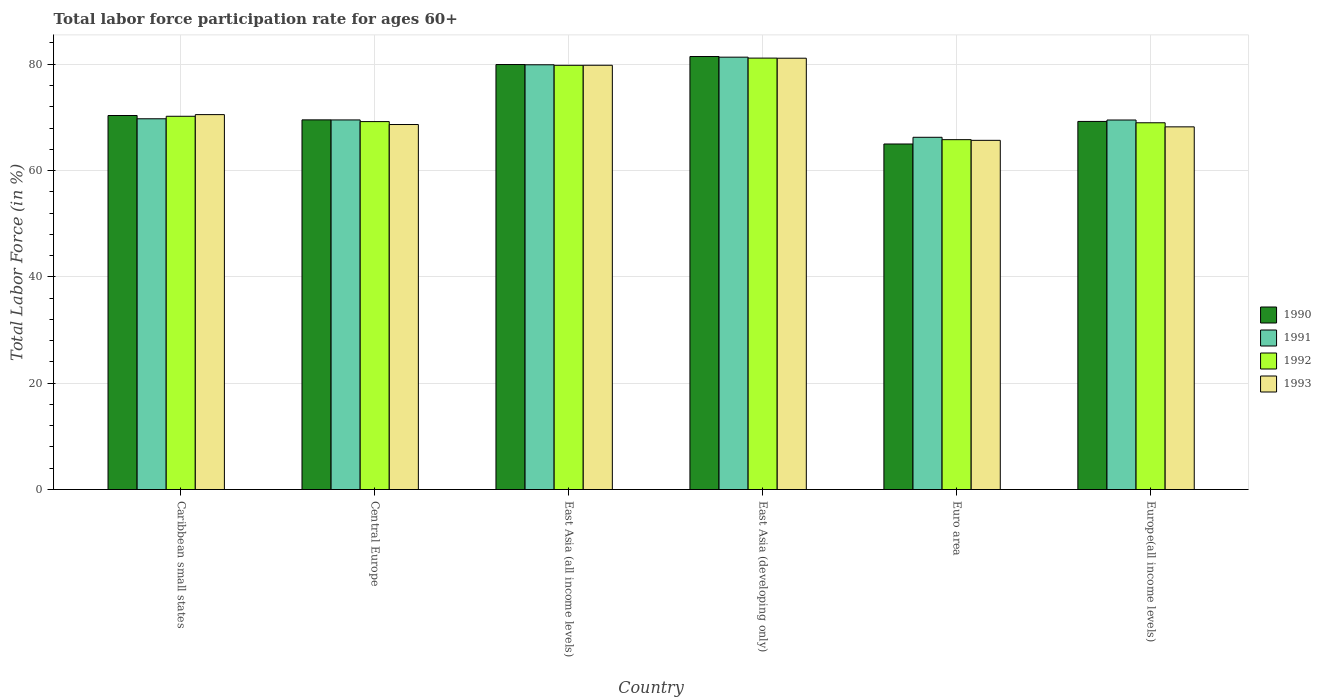How many different coloured bars are there?
Provide a succinct answer. 4. How many groups of bars are there?
Keep it short and to the point. 6. Are the number of bars on each tick of the X-axis equal?
Ensure brevity in your answer.  Yes. How many bars are there on the 1st tick from the left?
Give a very brief answer. 4. What is the label of the 4th group of bars from the left?
Provide a short and direct response. East Asia (developing only). In how many cases, is the number of bars for a given country not equal to the number of legend labels?
Make the answer very short. 0. What is the labor force participation rate in 1993 in East Asia (developing only)?
Your answer should be very brief. 81.14. Across all countries, what is the maximum labor force participation rate in 1993?
Give a very brief answer. 81.14. Across all countries, what is the minimum labor force participation rate in 1992?
Your answer should be very brief. 65.81. In which country was the labor force participation rate in 1992 maximum?
Provide a succinct answer. East Asia (developing only). In which country was the labor force participation rate in 1990 minimum?
Offer a very short reply. Euro area. What is the total labor force participation rate in 1992 in the graph?
Offer a terse response. 435.19. What is the difference between the labor force participation rate in 1990 in Central Europe and that in Europe(all income levels)?
Offer a very short reply. 0.29. What is the difference between the labor force participation rate in 1990 in Caribbean small states and the labor force participation rate in 1991 in East Asia (all income levels)?
Provide a short and direct response. -9.54. What is the average labor force participation rate in 1992 per country?
Give a very brief answer. 72.53. What is the difference between the labor force participation rate of/in 1990 and labor force participation rate of/in 1993 in Caribbean small states?
Make the answer very short. -0.17. What is the ratio of the labor force participation rate in 1991 in Central Europe to that in East Asia (all income levels)?
Keep it short and to the point. 0.87. What is the difference between the highest and the second highest labor force participation rate in 1992?
Provide a succinct answer. 10.94. What is the difference between the highest and the lowest labor force participation rate in 1993?
Ensure brevity in your answer.  15.45. In how many countries, is the labor force participation rate in 1993 greater than the average labor force participation rate in 1993 taken over all countries?
Offer a terse response. 2. Is the sum of the labor force participation rate in 1990 in Caribbean small states and East Asia (developing only) greater than the maximum labor force participation rate in 1991 across all countries?
Your answer should be compact. Yes. What does the 3rd bar from the left in East Asia (all income levels) represents?
Ensure brevity in your answer.  1992. What does the 3rd bar from the right in East Asia (all income levels) represents?
Keep it short and to the point. 1991. Is it the case that in every country, the sum of the labor force participation rate in 1993 and labor force participation rate in 1992 is greater than the labor force participation rate in 1990?
Your answer should be compact. Yes. How many bars are there?
Keep it short and to the point. 24. What is the difference between two consecutive major ticks on the Y-axis?
Give a very brief answer. 20. Where does the legend appear in the graph?
Your answer should be compact. Center right. What is the title of the graph?
Provide a short and direct response. Total labor force participation rate for ages 60+. What is the label or title of the X-axis?
Your response must be concise. Country. What is the Total Labor Force (in %) in 1990 in Caribbean small states?
Provide a short and direct response. 70.36. What is the Total Labor Force (in %) in 1991 in Caribbean small states?
Offer a very short reply. 69.74. What is the Total Labor Force (in %) of 1992 in Caribbean small states?
Ensure brevity in your answer.  70.21. What is the Total Labor Force (in %) in 1993 in Caribbean small states?
Offer a very short reply. 70.53. What is the Total Labor Force (in %) in 1990 in Central Europe?
Give a very brief answer. 69.54. What is the Total Labor Force (in %) of 1991 in Central Europe?
Offer a very short reply. 69.52. What is the Total Labor Force (in %) of 1992 in Central Europe?
Make the answer very short. 69.21. What is the Total Labor Force (in %) of 1993 in Central Europe?
Give a very brief answer. 68.66. What is the Total Labor Force (in %) of 1990 in East Asia (all income levels)?
Offer a very short reply. 79.95. What is the Total Labor Force (in %) of 1991 in East Asia (all income levels)?
Make the answer very short. 79.9. What is the Total Labor Force (in %) of 1992 in East Asia (all income levels)?
Your response must be concise. 79.8. What is the Total Labor Force (in %) of 1993 in East Asia (all income levels)?
Your response must be concise. 79.81. What is the Total Labor Force (in %) of 1990 in East Asia (developing only)?
Your response must be concise. 81.45. What is the Total Labor Force (in %) of 1991 in East Asia (developing only)?
Your answer should be very brief. 81.33. What is the Total Labor Force (in %) of 1992 in East Asia (developing only)?
Offer a very short reply. 81.16. What is the Total Labor Force (in %) of 1993 in East Asia (developing only)?
Your response must be concise. 81.14. What is the Total Labor Force (in %) of 1990 in Euro area?
Give a very brief answer. 65. What is the Total Labor Force (in %) in 1991 in Euro area?
Your response must be concise. 66.26. What is the Total Labor Force (in %) in 1992 in Euro area?
Give a very brief answer. 65.81. What is the Total Labor Force (in %) of 1993 in Euro area?
Your response must be concise. 65.69. What is the Total Labor Force (in %) of 1990 in Europe(all income levels)?
Keep it short and to the point. 69.24. What is the Total Labor Force (in %) in 1991 in Europe(all income levels)?
Make the answer very short. 69.51. What is the Total Labor Force (in %) in 1992 in Europe(all income levels)?
Provide a short and direct response. 68.99. What is the Total Labor Force (in %) of 1993 in Europe(all income levels)?
Keep it short and to the point. 68.22. Across all countries, what is the maximum Total Labor Force (in %) of 1990?
Keep it short and to the point. 81.45. Across all countries, what is the maximum Total Labor Force (in %) in 1991?
Give a very brief answer. 81.33. Across all countries, what is the maximum Total Labor Force (in %) in 1992?
Your answer should be compact. 81.16. Across all countries, what is the maximum Total Labor Force (in %) in 1993?
Offer a very short reply. 81.14. Across all countries, what is the minimum Total Labor Force (in %) of 1990?
Provide a short and direct response. 65. Across all countries, what is the minimum Total Labor Force (in %) in 1991?
Offer a terse response. 66.26. Across all countries, what is the minimum Total Labor Force (in %) of 1992?
Make the answer very short. 65.81. Across all countries, what is the minimum Total Labor Force (in %) of 1993?
Make the answer very short. 65.69. What is the total Total Labor Force (in %) of 1990 in the graph?
Make the answer very short. 435.54. What is the total Total Labor Force (in %) of 1991 in the graph?
Ensure brevity in your answer.  436.27. What is the total Total Labor Force (in %) in 1992 in the graph?
Give a very brief answer. 435.19. What is the total Total Labor Force (in %) of 1993 in the graph?
Give a very brief answer. 434.05. What is the difference between the Total Labor Force (in %) of 1990 in Caribbean small states and that in Central Europe?
Your response must be concise. 0.82. What is the difference between the Total Labor Force (in %) of 1991 in Caribbean small states and that in Central Europe?
Give a very brief answer. 0.22. What is the difference between the Total Labor Force (in %) in 1992 in Caribbean small states and that in Central Europe?
Give a very brief answer. 1. What is the difference between the Total Labor Force (in %) in 1993 in Caribbean small states and that in Central Europe?
Provide a succinct answer. 1.86. What is the difference between the Total Labor Force (in %) in 1990 in Caribbean small states and that in East Asia (all income levels)?
Your response must be concise. -9.59. What is the difference between the Total Labor Force (in %) in 1991 in Caribbean small states and that in East Asia (all income levels)?
Offer a terse response. -10.16. What is the difference between the Total Labor Force (in %) in 1992 in Caribbean small states and that in East Asia (all income levels)?
Make the answer very short. -9.59. What is the difference between the Total Labor Force (in %) of 1993 in Caribbean small states and that in East Asia (all income levels)?
Your response must be concise. -9.28. What is the difference between the Total Labor Force (in %) of 1990 in Caribbean small states and that in East Asia (developing only)?
Offer a very short reply. -11.1. What is the difference between the Total Labor Force (in %) in 1991 in Caribbean small states and that in East Asia (developing only)?
Your answer should be compact. -11.59. What is the difference between the Total Labor Force (in %) in 1992 in Caribbean small states and that in East Asia (developing only)?
Your answer should be compact. -10.94. What is the difference between the Total Labor Force (in %) in 1993 in Caribbean small states and that in East Asia (developing only)?
Your answer should be very brief. -10.61. What is the difference between the Total Labor Force (in %) in 1990 in Caribbean small states and that in Euro area?
Give a very brief answer. 5.36. What is the difference between the Total Labor Force (in %) in 1991 in Caribbean small states and that in Euro area?
Your answer should be compact. 3.48. What is the difference between the Total Labor Force (in %) in 1992 in Caribbean small states and that in Euro area?
Your answer should be compact. 4.4. What is the difference between the Total Labor Force (in %) of 1993 in Caribbean small states and that in Euro area?
Ensure brevity in your answer.  4.84. What is the difference between the Total Labor Force (in %) in 1990 in Caribbean small states and that in Europe(all income levels)?
Provide a short and direct response. 1.11. What is the difference between the Total Labor Force (in %) of 1991 in Caribbean small states and that in Europe(all income levels)?
Your answer should be very brief. 0.23. What is the difference between the Total Labor Force (in %) in 1992 in Caribbean small states and that in Europe(all income levels)?
Your response must be concise. 1.22. What is the difference between the Total Labor Force (in %) in 1993 in Caribbean small states and that in Europe(all income levels)?
Your answer should be very brief. 2.3. What is the difference between the Total Labor Force (in %) of 1990 in Central Europe and that in East Asia (all income levels)?
Make the answer very short. -10.41. What is the difference between the Total Labor Force (in %) of 1991 in Central Europe and that in East Asia (all income levels)?
Ensure brevity in your answer.  -10.38. What is the difference between the Total Labor Force (in %) of 1992 in Central Europe and that in East Asia (all income levels)?
Offer a very short reply. -10.59. What is the difference between the Total Labor Force (in %) in 1993 in Central Europe and that in East Asia (all income levels)?
Ensure brevity in your answer.  -11.15. What is the difference between the Total Labor Force (in %) of 1990 in Central Europe and that in East Asia (developing only)?
Offer a terse response. -11.92. What is the difference between the Total Labor Force (in %) of 1991 in Central Europe and that in East Asia (developing only)?
Your response must be concise. -11.81. What is the difference between the Total Labor Force (in %) of 1992 in Central Europe and that in East Asia (developing only)?
Provide a short and direct response. -11.95. What is the difference between the Total Labor Force (in %) in 1993 in Central Europe and that in East Asia (developing only)?
Offer a terse response. -12.48. What is the difference between the Total Labor Force (in %) of 1990 in Central Europe and that in Euro area?
Offer a very short reply. 4.54. What is the difference between the Total Labor Force (in %) in 1991 in Central Europe and that in Euro area?
Provide a short and direct response. 3.27. What is the difference between the Total Labor Force (in %) in 1992 in Central Europe and that in Euro area?
Offer a very short reply. 3.4. What is the difference between the Total Labor Force (in %) of 1993 in Central Europe and that in Euro area?
Give a very brief answer. 2.98. What is the difference between the Total Labor Force (in %) in 1990 in Central Europe and that in Europe(all income levels)?
Provide a short and direct response. 0.29. What is the difference between the Total Labor Force (in %) of 1991 in Central Europe and that in Europe(all income levels)?
Ensure brevity in your answer.  0.01. What is the difference between the Total Labor Force (in %) in 1992 in Central Europe and that in Europe(all income levels)?
Offer a very short reply. 0.22. What is the difference between the Total Labor Force (in %) in 1993 in Central Europe and that in Europe(all income levels)?
Offer a very short reply. 0.44. What is the difference between the Total Labor Force (in %) in 1990 in East Asia (all income levels) and that in East Asia (developing only)?
Provide a short and direct response. -1.51. What is the difference between the Total Labor Force (in %) of 1991 in East Asia (all income levels) and that in East Asia (developing only)?
Your answer should be very brief. -1.43. What is the difference between the Total Labor Force (in %) of 1992 in East Asia (all income levels) and that in East Asia (developing only)?
Offer a terse response. -1.36. What is the difference between the Total Labor Force (in %) of 1993 in East Asia (all income levels) and that in East Asia (developing only)?
Offer a very short reply. -1.33. What is the difference between the Total Labor Force (in %) of 1990 in East Asia (all income levels) and that in Euro area?
Provide a short and direct response. 14.95. What is the difference between the Total Labor Force (in %) of 1991 in East Asia (all income levels) and that in Euro area?
Provide a succinct answer. 13.64. What is the difference between the Total Labor Force (in %) in 1992 in East Asia (all income levels) and that in Euro area?
Keep it short and to the point. 13.99. What is the difference between the Total Labor Force (in %) of 1993 in East Asia (all income levels) and that in Euro area?
Make the answer very short. 14.12. What is the difference between the Total Labor Force (in %) of 1990 in East Asia (all income levels) and that in Europe(all income levels)?
Offer a very short reply. 10.7. What is the difference between the Total Labor Force (in %) in 1991 in East Asia (all income levels) and that in Europe(all income levels)?
Keep it short and to the point. 10.39. What is the difference between the Total Labor Force (in %) in 1992 in East Asia (all income levels) and that in Europe(all income levels)?
Provide a succinct answer. 10.81. What is the difference between the Total Labor Force (in %) of 1993 in East Asia (all income levels) and that in Europe(all income levels)?
Offer a very short reply. 11.59. What is the difference between the Total Labor Force (in %) in 1990 in East Asia (developing only) and that in Euro area?
Your answer should be compact. 16.45. What is the difference between the Total Labor Force (in %) in 1991 in East Asia (developing only) and that in Euro area?
Your answer should be compact. 15.07. What is the difference between the Total Labor Force (in %) of 1992 in East Asia (developing only) and that in Euro area?
Your answer should be very brief. 15.34. What is the difference between the Total Labor Force (in %) of 1993 in East Asia (developing only) and that in Euro area?
Ensure brevity in your answer.  15.45. What is the difference between the Total Labor Force (in %) in 1990 in East Asia (developing only) and that in Europe(all income levels)?
Make the answer very short. 12.21. What is the difference between the Total Labor Force (in %) in 1991 in East Asia (developing only) and that in Europe(all income levels)?
Your answer should be compact. 11.82. What is the difference between the Total Labor Force (in %) in 1992 in East Asia (developing only) and that in Europe(all income levels)?
Ensure brevity in your answer.  12.17. What is the difference between the Total Labor Force (in %) in 1993 in East Asia (developing only) and that in Europe(all income levels)?
Offer a very short reply. 12.91. What is the difference between the Total Labor Force (in %) in 1990 in Euro area and that in Europe(all income levels)?
Provide a short and direct response. -4.24. What is the difference between the Total Labor Force (in %) in 1991 in Euro area and that in Europe(all income levels)?
Offer a terse response. -3.25. What is the difference between the Total Labor Force (in %) in 1992 in Euro area and that in Europe(all income levels)?
Give a very brief answer. -3.18. What is the difference between the Total Labor Force (in %) of 1993 in Euro area and that in Europe(all income levels)?
Your answer should be compact. -2.54. What is the difference between the Total Labor Force (in %) in 1990 in Caribbean small states and the Total Labor Force (in %) in 1991 in Central Europe?
Your response must be concise. 0.83. What is the difference between the Total Labor Force (in %) in 1990 in Caribbean small states and the Total Labor Force (in %) in 1992 in Central Europe?
Ensure brevity in your answer.  1.15. What is the difference between the Total Labor Force (in %) of 1990 in Caribbean small states and the Total Labor Force (in %) of 1993 in Central Europe?
Give a very brief answer. 1.7. What is the difference between the Total Labor Force (in %) in 1991 in Caribbean small states and the Total Labor Force (in %) in 1992 in Central Europe?
Offer a terse response. 0.53. What is the difference between the Total Labor Force (in %) in 1991 in Caribbean small states and the Total Labor Force (in %) in 1993 in Central Europe?
Offer a very short reply. 1.08. What is the difference between the Total Labor Force (in %) in 1992 in Caribbean small states and the Total Labor Force (in %) in 1993 in Central Europe?
Keep it short and to the point. 1.55. What is the difference between the Total Labor Force (in %) of 1990 in Caribbean small states and the Total Labor Force (in %) of 1991 in East Asia (all income levels)?
Provide a short and direct response. -9.54. What is the difference between the Total Labor Force (in %) of 1990 in Caribbean small states and the Total Labor Force (in %) of 1992 in East Asia (all income levels)?
Provide a short and direct response. -9.44. What is the difference between the Total Labor Force (in %) in 1990 in Caribbean small states and the Total Labor Force (in %) in 1993 in East Asia (all income levels)?
Your answer should be very brief. -9.45. What is the difference between the Total Labor Force (in %) in 1991 in Caribbean small states and the Total Labor Force (in %) in 1992 in East Asia (all income levels)?
Your response must be concise. -10.06. What is the difference between the Total Labor Force (in %) of 1991 in Caribbean small states and the Total Labor Force (in %) of 1993 in East Asia (all income levels)?
Give a very brief answer. -10.07. What is the difference between the Total Labor Force (in %) in 1992 in Caribbean small states and the Total Labor Force (in %) in 1993 in East Asia (all income levels)?
Provide a short and direct response. -9.6. What is the difference between the Total Labor Force (in %) of 1990 in Caribbean small states and the Total Labor Force (in %) of 1991 in East Asia (developing only)?
Provide a succinct answer. -10.97. What is the difference between the Total Labor Force (in %) in 1990 in Caribbean small states and the Total Labor Force (in %) in 1992 in East Asia (developing only)?
Your answer should be compact. -10.8. What is the difference between the Total Labor Force (in %) in 1990 in Caribbean small states and the Total Labor Force (in %) in 1993 in East Asia (developing only)?
Your response must be concise. -10.78. What is the difference between the Total Labor Force (in %) in 1991 in Caribbean small states and the Total Labor Force (in %) in 1992 in East Asia (developing only)?
Provide a succinct answer. -11.42. What is the difference between the Total Labor Force (in %) in 1991 in Caribbean small states and the Total Labor Force (in %) in 1993 in East Asia (developing only)?
Your answer should be compact. -11.4. What is the difference between the Total Labor Force (in %) of 1992 in Caribbean small states and the Total Labor Force (in %) of 1993 in East Asia (developing only)?
Your response must be concise. -10.92. What is the difference between the Total Labor Force (in %) in 1990 in Caribbean small states and the Total Labor Force (in %) in 1991 in Euro area?
Your response must be concise. 4.1. What is the difference between the Total Labor Force (in %) in 1990 in Caribbean small states and the Total Labor Force (in %) in 1992 in Euro area?
Ensure brevity in your answer.  4.55. What is the difference between the Total Labor Force (in %) in 1990 in Caribbean small states and the Total Labor Force (in %) in 1993 in Euro area?
Provide a short and direct response. 4.67. What is the difference between the Total Labor Force (in %) of 1991 in Caribbean small states and the Total Labor Force (in %) of 1992 in Euro area?
Your answer should be compact. 3.93. What is the difference between the Total Labor Force (in %) in 1991 in Caribbean small states and the Total Labor Force (in %) in 1993 in Euro area?
Ensure brevity in your answer.  4.06. What is the difference between the Total Labor Force (in %) in 1992 in Caribbean small states and the Total Labor Force (in %) in 1993 in Euro area?
Your response must be concise. 4.53. What is the difference between the Total Labor Force (in %) in 1990 in Caribbean small states and the Total Labor Force (in %) in 1991 in Europe(all income levels)?
Your answer should be very brief. 0.85. What is the difference between the Total Labor Force (in %) in 1990 in Caribbean small states and the Total Labor Force (in %) in 1992 in Europe(all income levels)?
Your answer should be very brief. 1.37. What is the difference between the Total Labor Force (in %) in 1990 in Caribbean small states and the Total Labor Force (in %) in 1993 in Europe(all income levels)?
Provide a short and direct response. 2.13. What is the difference between the Total Labor Force (in %) of 1991 in Caribbean small states and the Total Labor Force (in %) of 1992 in Europe(all income levels)?
Ensure brevity in your answer.  0.75. What is the difference between the Total Labor Force (in %) in 1991 in Caribbean small states and the Total Labor Force (in %) in 1993 in Europe(all income levels)?
Your answer should be very brief. 1.52. What is the difference between the Total Labor Force (in %) of 1992 in Caribbean small states and the Total Labor Force (in %) of 1993 in Europe(all income levels)?
Provide a succinct answer. 1.99. What is the difference between the Total Labor Force (in %) in 1990 in Central Europe and the Total Labor Force (in %) in 1991 in East Asia (all income levels)?
Your answer should be compact. -10.37. What is the difference between the Total Labor Force (in %) of 1990 in Central Europe and the Total Labor Force (in %) of 1992 in East Asia (all income levels)?
Provide a succinct answer. -10.27. What is the difference between the Total Labor Force (in %) in 1990 in Central Europe and the Total Labor Force (in %) in 1993 in East Asia (all income levels)?
Offer a very short reply. -10.27. What is the difference between the Total Labor Force (in %) in 1991 in Central Europe and the Total Labor Force (in %) in 1992 in East Asia (all income levels)?
Provide a short and direct response. -10.28. What is the difference between the Total Labor Force (in %) of 1991 in Central Europe and the Total Labor Force (in %) of 1993 in East Asia (all income levels)?
Provide a short and direct response. -10.28. What is the difference between the Total Labor Force (in %) of 1992 in Central Europe and the Total Labor Force (in %) of 1993 in East Asia (all income levels)?
Ensure brevity in your answer.  -10.6. What is the difference between the Total Labor Force (in %) in 1990 in Central Europe and the Total Labor Force (in %) in 1991 in East Asia (developing only)?
Your answer should be very brief. -11.8. What is the difference between the Total Labor Force (in %) in 1990 in Central Europe and the Total Labor Force (in %) in 1992 in East Asia (developing only)?
Offer a terse response. -11.62. What is the difference between the Total Labor Force (in %) of 1990 in Central Europe and the Total Labor Force (in %) of 1993 in East Asia (developing only)?
Your answer should be very brief. -11.6. What is the difference between the Total Labor Force (in %) in 1991 in Central Europe and the Total Labor Force (in %) in 1992 in East Asia (developing only)?
Make the answer very short. -11.63. What is the difference between the Total Labor Force (in %) of 1991 in Central Europe and the Total Labor Force (in %) of 1993 in East Asia (developing only)?
Your response must be concise. -11.61. What is the difference between the Total Labor Force (in %) in 1992 in Central Europe and the Total Labor Force (in %) in 1993 in East Asia (developing only)?
Ensure brevity in your answer.  -11.93. What is the difference between the Total Labor Force (in %) of 1990 in Central Europe and the Total Labor Force (in %) of 1991 in Euro area?
Make the answer very short. 3.28. What is the difference between the Total Labor Force (in %) of 1990 in Central Europe and the Total Labor Force (in %) of 1992 in Euro area?
Your response must be concise. 3.72. What is the difference between the Total Labor Force (in %) in 1990 in Central Europe and the Total Labor Force (in %) in 1993 in Euro area?
Make the answer very short. 3.85. What is the difference between the Total Labor Force (in %) in 1991 in Central Europe and the Total Labor Force (in %) in 1992 in Euro area?
Give a very brief answer. 3.71. What is the difference between the Total Labor Force (in %) of 1991 in Central Europe and the Total Labor Force (in %) of 1993 in Euro area?
Provide a short and direct response. 3.84. What is the difference between the Total Labor Force (in %) in 1992 in Central Europe and the Total Labor Force (in %) in 1993 in Euro area?
Offer a very short reply. 3.53. What is the difference between the Total Labor Force (in %) in 1990 in Central Europe and the Total Labor Force (in %) in 1991 in Europe(all income levels)?
Give a very brief answer. 0.02. What is the difference between the Total Labor Force (in %) in 1990 in Central Europe and the Total Labor Force (in %) in 1992 in Europe(all income levels)?
Provide a short and direct response. 0.54. What is the difference between the Total Labor Force (in %) of 1990 in Central Europe and the Total Labor Force (in %) of 1993 in Europe(all income levels)?
Ensure brevity in your answer.  1.31. What is the difference between the Total Labor Force (in %) of 1991 in Central Europe and the Total Labor Force (in %) of 1992 in Europe(all income levels)?
Offer a very short reply. 0.53. What is the difference between the Total Labor Force (in %) of 1991 in Central Europe and the Total Labor Force (in %) of 1993 in Europe(all income levels)?
Ensure brevity in your answer.  1.3. What is the difference between the Total Labor Force (in %) in 1992 in Central Europe and the Total Labor Force (in %) in 1993 in Europe(all income levels)?
Your answer should be compact. 0.99. What is the difference between the Total Labor Force (in %) of 1990 in East Asia (all income levels) and the Total Labor Force (in %) of 1991 in East Asia (developing only)?
Give a very brief answer. -1.39. What is the difference between the Total Labor Force (in %) in 1990 in East Asia (all income levels) and the Total Labor Force (in %) in 1992 in East Asia (developing only)?
Your answer should be very brief. -1.21. What is the difference between the Total Labor Force (in %) of 1990 in East Asia (all income levels) and the Total Labor Force (in %) of 1993 in East Asia (developing only)?
Provide a short and direct response. -1.19. What is the difference between the Total Labor Force (in %) of 1991 in East Asia (all income levels) and the Total Labor Force (in %) of 1992 in East Asia (developing only)?
Keep it short and to the point. -1.26. What is the difference between the Total Labor Force (in %) of 1991 in East Asia (all income levels) and the Total Labor Force (in %) of 1993 in East Asia (developing only)?
Ensure brevity in your answer.  -1.24. What is the difference between the Total Labor Force (in %) of 1992 in East Asia (all income levels) and the Total Labor Force (in %) of 1993 in East Asia (developing only)?
Keep it short and to the point. -1.34. What is the difference between the Total Labor Force (in %) in 1990 in East Asia (all income levels) and the Total Labor Force (in %) in 1991 in Euro area?
Offer a terse response. 13.69. What is the difference between the Total Labor Force (in %) of 1990 in East Asia (all income levels) and the Total Labor Force (in %) of 1992 in Euro area?
Offer a terse response. 14.13. What is the difference between the Total Labor Force (in %) of 1990 in East Asia (all income levels) and the Total Labor Force (in %) of 1993 in Euro area?
Keep it short and to the point. 14.26. What is the difference between the Total Labor Force (in %) in 1991 in East Asia (all income levels) and the Total Labor Force (in %) in 1992 in Euro area?
Offer a very short reply. 14.09. What is the difference between the Total Labor Force (in %) in 1991 in East Asia (all income levels) and the Total Labor Force (in %) in 1993 in Euro area?
Provide a succinct answer. 14.22. What is the difference between the Total Labor Force (in %) of 1992 in East Asia (all income levels) and the Total Labor Force (in %) of 1993 in Euro area?
Provide a short and direct response. 14.12. What is the difference between the Total Labor Force (in %) in 1990 in East Asia (all income levels) and the Total Labor Force (in %) in 1991 in Europe(all income levels)?
Keep it short and to the point. 10.43. What is the difference between the Total Labor Force (in %) of 1990 in East Asia (all income levels) and the Total Labor Force (in %) of 1992 in Europe(all income levels)?
Offer a very short reply. 10.95. What is the difference between the Total Labor Force (in %) of 1990 in East Asia (all income levels) and the Total Labor Force (in %) of 1993 in Europe(all income levels)?
Give a very brief answer. 11.72. What is the difference between the Total Labor Force (in %) of 1991 in East Asia (all income levels) and the Total Labor Force (in %) of 1992 in Europe(all income levels)?
Keep it short and to the point. 10.91. What is the difference between the Total Labor Force (in %) in 1991 in East Asia (all income levels) and the Total Labor Force (in %) in 1993 in Europe(all income levels)?
Provide a succinct answer. 11.68. What is the difference between the Total Labor Force (in %) of 1992 in East Asia (all income levels) and the Total Labor Force (in %) of 1993 in Europe(all income levels)?
Your response must be concise. 11.58. What is the difference between the Total Labor Force (in %) of 1990 in East Asia (developing only) and the Total Labor Force (in %) of 1991 in Euro area?
Make the answer very short. 15.19. What is the difference between the Total Labor Force (in %) of 1990 in East Asia (developing only) and the Total Labor Force (in %) of 1992 in Euro area?
Provide a short and direct response. 15.64. What is the difference between the Total Labor Force (in %) in 1990 in East Asia (developing only) and the Total Labor Force (in %) in 1993 in Euro area?
Offer a very short reply. 15.77. What is the difference between the Total Labor Force (in %) in 1991 in East Asia (developing only) and the Total Labor Force (in %) in 1992 in Euro area?
Provide a short and direct response. 15.52. What is the difference between the Total Labor Force (in %) of 1991 in East Asia (developing only) and the Total Labor Force (in %) of 1993 in Euro area?
Ensure brevity in your answer.  15.65. What is the difference between the Total Labor Force (in %) in 1992 in East Asia (developing only) and the Total Labor Force (in %) in 1993 in Euro area?
Your answer should be compact. 15.47. What is the difference between the Total Labor Force (in %) in 1990 in East Asia (developing only) and the Total Labor Force (in %) in 1991 in Europe(all income levels)?
Ensure brevity in your answer.  11.94. What is the difference between the Total Labor Force (in %) in 1990 in East Asia (developing only) and the Total Labor Force (in %) in 1992 in Europe(all income levels)?
Your answer should be compact. 12.46. What is the difference between the Total Labor Force (in %) of 1990 in East Asia (developing only) and the Total Labor Force (in %) of 1993 in Europe(all income levels)?
Give a very brief answer. 13.23. What is the difference between the Total Labor Force (in %) in 1991 in East Asia (developing only) and the Total Labor Force (in %) in 1992 in Europe(all income levels)?
Your response must be concise. 12.34. What is the difference between the Total Labor Force (in %) of 1991 in East Asia (developing only) and the Total Labor Force (in %) of 1993 in Europe(all income levels)?
Offer a terse response. 13.11. What is the difference between the Total Labor Force (in %) of 1992 in East Asia (developing only) and the Total Labor Force (in %) of 1993 in Europe(all income levels)?
Your response must be concise. 12.93. What is the difference between the Total Labor Force (in %) of 1990 in Euro area and the Total Labor Force (in %) of 1991 in Europe(all income levels)?
Provide a succinct answer. -4.51. What is the difference between the Total Labor Force (in %) in 1990 in Euro area and the Total Labor Force (in %) in 1992 in Europe(all income levels)?
Your response must be concise. -3.99. What is the difference between the Total Labor Force (in %) in 1990 in Euro area and the Total Labor Force (in %) in 1993 in Europe(all income levels)?
Provide a short and direct response. -3.22. What is the difference between the Total Labor Force (in %) in 1991 in Euro area and the Total Labor Force (in %) in 1992 in Europe(all income levels)?
Make the answer very short. -2.73. What is the difference between the Total Labor Force (in %) in 1991 in Euro area and the Total Labor Force (in %) in 1993 in Europe(all income levels)?
Provide a succinct answer. -1.97. What is the difference between the Total Labor Force (in %) in 1992 in Euro area and the Total Labor Force (in %) in 1993 in Europe(all income levels)?
Provide a succinct answer. -2.41. What is the average Total Labor Force (in %) in 1990 per country?
Offer a very short reply. 72.59. What is the average Total Labor Force (in %) of 1991 per country?
Your response must be concise. 72.71. What is the average Total Labor Force (in %) in 1992 per country?
Offer a very short reply. 72.53. What is the average Total Labor Force (in %) in 1993 per country?
Offer a terse response. 72.34. What is the difference between the Total Labor Force (in %) in 1990 and Total Labor Force (in %) in 1991 in Caribbean small states?
Offer a terse response. 0.62. What is the difference between the Total Labor Force (in %) in 1990 and Total Labor Force (in %) in 1992 in Caribbean small states?
Your answer should be compact. 0.14. What is the difference between the Total Labor Force (in %) in 1990 and Total Labor Force (in %) in 1993 in Caribbean small states?
Make the answer very short. -0.17. What is the difference between the Total Labor Force (in %) in 1991 and Total Labor Force (in %) in 1992 in Caribbean small states?
Your answer should be compact. -0.47. What is the difference between the Total Labor Force (in %) of 1991 and Total Labor Force (in %) of 1993 in Caribbean small states?
Give a very brief answer. -0.78. What is the difference between the Total Labor Force (in %) of 1992 and Total Labor Force (in %) of 1993 in Caribbean small states?
Keep it short and to the point. -0.31. What is the difference between the Total Labor Force (in %) in 1990 and Total Labor Force (in %) in 1991 in Central Europe?
Provide a short and direct response. 0.01. What is the difference between the Total Labor Force (in %) of 1990 and Total Labor Force (in %) of 1992 in Central Europe?
Give a very brief answer. 0.32. What is the difference between the Total Labor Force (in %) in 1990 and Total Labor Force (in %) in 1993 in Central Europe?
Ensure brevity in your answer.  0.87. What is the difference between the Total Labor Force (in %) of 1991 and Total Labor Force (in %) of 1992 in Central Europe?
Provide a short and direct response. 0.31. What is the difference between the Total Labor Force (in %) of 1991 and Total Labor Force (in %) of 1993 in Central Europe?
Offer a very short reply. 0.86. What is the difference between the Total Labor Force (in %) in 1992 and Total Labor Force (in %) in 1993 in Central Europe?
Ensure brevity in your answer.  0.55. What is the difference between the Total Labor Force (in %) in 1990 and Total Labor Force (in %) in 1991 in East Asia (all income levels)?
Offer a terse response. 0.04. What is the difference between the Total Labor Force (in %) of 1990 and Total Labor Force (in %) of 1992 in East Asia (all income levels)?
Keep it short and to the point. 0.14. What is the difference between the Total Labor Force (in %) of 1990 and Total Labor Force (in %) of 1993 in East Asia (all income levels)?
Offer a terse response. 0.14. What is the difference between the Total Labor Force (in %) of 1991 and Total Labor Force (in %) of 1992 in East Asia (all income levels)?
Offer a terse response. 0.1. What is the difference between the Total Labor Force (in %) of 1991 and Total Labor Force (in %) of 1993 in East Asia (all income levels)?
Give a very brief answer. 0.09. What is the difference between the Total Labor Force (in %) of 1992 and Total Labor Force (in %) of 1993 in East Asia (all income levels)?
Provide a short and direct response. -0.01. What is the difference between the Total Labor Force (in %) in 1990 and Total Labor Force (in %) in 1991 in East Asia (developing only)?
Ensure brevity in your answer.  0.12. What is the difference between the Total Labor Force (in %) in 1990 and Total Labor Force (in %) in 1992 in East Asia (developing only)?
Keep it short and to the point. 0.3. What is the difference between the Total Labor Force (in %) of 1990 and Total Labor Force (in %) of 1993 in East Asia (developing only)?
Give a very brief answer. 0.32. What is the difference between the Total Labor Force (in %) of 1991 and Total Labor Force (in %) of 1992 in East Asia (developing only)?
Give a very brief answer. 0.17. What is the difference between the Total Labor Force (in %) of 1991 and Total Labor Force (in %) of 1993 in East Asia (developing only)?
Provide a short and direct response. 0.19. What is the difference between the Total Labor Force (in %) in 1992 and Total Labor Force (in %) in 1993 in East Asia (developing only)?
Your response must be concise. 0.02. What is the difference between the Total Labor Force (in %) in 1990 and Total Labor Force (in %) in 1991 in Euro area?
Your response must be concise. -1.26. What is the difference between the Total Labor Force (in %) in 1990 and Total Labor Force (in %) in 1992 in Euro area?
Keep it short and to the point. -0.81. What is the difference between the Total Labor Force (in %) of 1990 and Total Labor Force (in %) of 1993 in Euro area?
Your answer should be compact. -0.69. What is the difference between the Total Labor Force (in %) of 1991 and Total Labor Force (in %) of 1992 in Euro area?
Your response must be concise. 0.45. What is the difference between the Total Labor Force (in %) in 1991 and Total Labor Force (in %) in 1993 in Euro area?
Offer a terse response. 0.57. What is the difference between the Total Labor Force (in %) in 1992 and Total Labor Force (in %) in 1993 in Euro area?
Ensure brevity in your answer.  0.13. What is the difference between the Total Labor Force (in %) of 1990 and Total Labor Force (in %) of 1991 in Europe(all income levels)?
Give a very brief answer. -0.27. What is the difference between the Total Labor Force (in %) in 1990 and Total Labor Force (in %) in 1992 in Europe(all income levels)?
Your response must be concise. 0.25. What is the difference between the Total Labor Force (in %) in 1990 and Total Labor Force (in %) in 1993 in Europe(all income levels)?
Your response must be concise. 1.02. What is the difference between the Total Labor Force (in %) in 1991 and Total Labor Force (in %) in 1992 in Europe(all income levels)?
Your answer should be compact. 0.52. What is the difference between the Total Labor Force (in %) in 1991 and Total Labor Force (in %) in 1993 in Europe(all income levels)?
Provide a short and direct response. 1.29. What is the difference between the Total Labor Force (in %) in 1992 and Total Labor Force (in %) in 1993 in Europe(all income levels)?
Give a very brief answer. 0.77. What is the ratio of the Total Labor Force (in %) in 1990 in Caribbean small states to that in Central Europe?
Offer a very short reply. 1.01. What is the ratio of the Total Labor Force (in %) in 1992 in Caribbean small states to that in Central Europe?
Give a very brief answer. 1.01. What is the ratio of the Total Labor Force (in %) of 1993 in Caribbean small states to that in Central Europe?
Give a very brief answer. 1.03. What is the ratio of the Total Labor Force (in %) in 1990 in Caribbean small states to that in East Asia (all income levels)?
Your answer should be very brief. 0.88. What is the ratio of the Total Labor Force (in %) in 1991 in Caribbean small states to that in East Asia (all income levels)?
Ensure brevity in your answer.  0.87. What is the ratio of the Total Labor Force (in %) of 1992 in Caribbean small states to that in East Asia (all income levels)?
Ensure brevity in your answer.  0.88. What is the ratio of the Total Labor Force (in %) of 1993 in Caribbean small states to that in East Asia (all income levels)?
Your answer should be compact. 0.88. What is the ratio of the Total Labor Force (in %) of 1990 in Caribbean small states to that in East Asia (developing only)?
Offer a very short reply. 0.86. What is the ratio of the Total Labor Force (in %) of 1991 in Caribbean small states to that in East Asia (developing only)?
Make the answer very short. 0.86. What is the ratio of the Total Labor Force (in %) of 1992 in Caribbean small states to that in East Asia (developing only)?
Offer a very short reply. 0.87. What is the ratio of the Total Labor Force (in %) in 1993 in Caribbean small states to that in East Asia (developing only)?
Provide a succinct answer. 0.87. What is the ratio of the Total Labor Force (in %) of 1990 in Caribbean small states to that in Euro area?
Offer a very short reply. 1.08. What is the ratio of the Total Labor Force (in %) in 1991 in Caribbean small states to that in Euro area?
Keep it short and to the point. 1.05. What is the ratio of the Total Labor Force (in %) of 1992 in Caribbean small states to that in Euro area?
Ensure brevity in your answer.  1.07. What is the ratio of the Total Labor Force (in %) in 1993 in Caribbean small states to that in Euro area?
Keep it short and to the point. 1.07. What is the ratio of the Total Labor Force (in %) in 1990 in Caribbean small states to that in Europe(all income levels)?
Your answer should be compact. 1.02. What is the ratio of the Total Labor Force (in %) of 1992 in Caribbean small states to that in Europe(all income levels)?
Provide a short and direct response. 1.02. What is the ratio of the Total Labor Force (in %) of 1993 in Caribbean small states to that in Europe(all income levels)?
Give a very brief answer. 1.03. What is the ratio of the Total Labor Force (in %) in 1990 in Central Europe to that in East Asia (all income levels)?
Your response must be concise. 0.87. What is the ratio of the Total Labor Force (in %) in 1991 in Central Europe to that in East Asia (all income levels)?
Ensure brevity in your answer.  0.87. What is the ratio of the Total Labor Force (in %) in 1992 in Central Europe to that in East Asia (all income levels)?
Provide a short and direct response. 0.87. What is the ratio of the Total Labor Force (in %) in 1993 in Central Europe to that in East Asia (all income levels)?
Keep it short and to the point. 0.86. What is the ratio of the Total Labor Force (in %) of 1990 in Central Europe to that in East Asia (developing only)?
Your answer should be compact. 0.85. What is the ratio of the Total Labor Force (in %) in 1991 in Central Europe to that in East Asia (developing only)?
Your answer should be very brief. 0.85. What is the ratio of the Total Labor Force (in %) of 1992 in Central Europe to that in East Asia (developing only)?
Give a very brief answer. 0.85. What is the ratio of the Total Labor Force (in %) of 1993 in Central Europe to that in East Asia (developing only)?
Your answer should be very brief. 0.85. What is the ratio of the Total Labor Force (in %) of 1990 in Central Europe to that in Euro area?
Offer a terse response. 1.07. What is the ratio of the Total Labor Force (in %) in 1991 in Central Europe to that in Euro area?
Provide a succinct answer. 1.05. What is the ratio of the Total Labor Force (in %) of 1992 in Central Europe to that in Euro area?
Offer a terse response. 1.05. What is the ratio of the Total Labor Force (in %) of 1993 in Central Europe to that in Euro area?
Your response must be concise. 1.05. What is the ratio of the Total Labor Force (in %) of 1993 in Central Europe to that in Europe(all income levels)?
Make the answer very short. 1.01. What is the ratio of the Total Labor Force (in %) of 1990 in East Asia (all income levels) to that in East Asia (developing only)?
Your response must be concise. 0.98. What is the ratio of the Total Labor Force (in %) in 1991 in East Asia (all income levels) to that in East Asia (developing only)?
Give a very brief answer. 0.98. What is the ratio of the Total Labor Force (in %) of 1992 in East Asia (all income levels) to that in East Asia (developing only)?
Your response must be concise. 0.98. What is the ratio of the Total Labor Force (in %) in 1993 in East Asia (all income levels) to that in East Asia (developing only)?
Make the answer very short. 0.98. What is the ratio of the Total Labor Force (in %) in 1990 in East Asia (all income levels) to that in Euro area?
Provide a succinct answer. 1.23. What is the ratio of the Total Labor Force (in %) in 1991 in East Asia (all income levels) to that in Euro area?
Your response must be concise. 1.21. What is the ratio of the Total Labor Force (in %) of 1992 in East Asia (all income levels) to that in Euro area?
Ensure brevity in your answer.  1.21. What is the ratio of the Total Labor Force (in %) in 1993 in East Asia (all income levels) to that in Euro area?
Provide a short and direct response. 1.22. What is the ratio of the Total Labor Force (in %) in 1990 in East Asia (all income levels) to that in Europe(all income levels)?
Ensure brevity in your answer.  1.15. What is the ratio of the Total Labor Force (in %) in 1991 in East Asia (all income levels) to that in Europe(all income levels)?
Keep it short and to the point. 1.15. What is the ratio of the Total Labor Force (in %) of 1992 in East Asia (all income levels) to that in Europe(all income levels)?
Your answer should be very brief. 1.16. What is the ratio of the Total Labor Force (in %) in 1993 in East Asia (all income levels) to that in Europe(all income levels)?
Ensure brevity in your answer.  1.17. What is the ratio of the Total Labor Force (in %) of 1990 in East Asia (developing only) to that in Euro area?
Provide a short and direct response. 1.25. What is the ratio of the Total Labor Force (in %) in 1991 in East Asia (developing only) to that in Euro area?
Your response must be concise. 1.23. What is the ratio of the Total Labor Force (in %) of 1992 in East Asia (developing only) to that in Euro area?
Keep it short and to the point. 1.23. What is the ratio of the Total Labor Force (in %) in 1993 in East Asia (developing only) to that in Euro area?
Offer a terse response. 1.24. What is the ratio of the Total Labor Force (in %) of 1990 in East Asia (developing only) to that in Europe(all income levels)?
Provide a succinct answer. 1.18. What is the ratio of the Total Labor Force (in %) in 1991 in East Asia (developing only) to that in Europe(all income levels)?
Ensure brevity in your answer.  1.17. What is the ratio of the Total Labor Force (in %) of 1992 in East Asia (developing only) to that in Europe(all income levels)?
Keep it short and to the point. 1.18. What is the ratio of the Total Labor Force (in %) of 1993 in East Asia (developing only) to that in Europe(all income levels)?
Make the answer very short. 1.19. What is the ratio of the Total Labor Force (in %) of 1990 in Euro area to that in Europe(all income levels)?
Offer a very short reply. 0.94. What is the ratio of the Total Labor Force (in %) in 1991 in Euro area to that in Europe(all income levels)?
Your response must be concise. 0.95. What is the ratio of the Total Labor Force (in %) in 1992 in Euro area to that in Europe(all income levels)?
Provide a short and direct response. 0.95. What is the ratio of the Total Labor Force (in %) of 1993 in Euro area to that in Europe(all income levels)?
Provide a succinct answer. 0.96. What is the difference between the highest and the second highest Total Labor Force (in %) in 1990?
Offer a terse response. 1.51. What is the difference between the highest and the second highest Total Labor Force (in %) in 1991?
Offer a terse response. 1.43. What is the difference between the highest and the second highest Total Labor Force (in %) of 1992?
Provide a short and direct response. 1.36. What is the difference between the highest and the second highest Total Labor Force (in %) of 1993?
Your response must be concise. 1.33. What is the difference between the highest and the lowest Total Labor Force (in %) in 1990?
Ensure brevity in your answer.  16.45. What is the difference between the highest and the lowest Total Labor Force (in %) in 1991?
Ensure brevity in your answer.  15.07. What is the difference between the highest and the lowest Total Labor Force (in %) of 1992?
Offer a terse response. 15.34. What is the difference between the highest and the lowest Total Labor Force (in %) in 1993?
Your response must be concise. 15.45. 